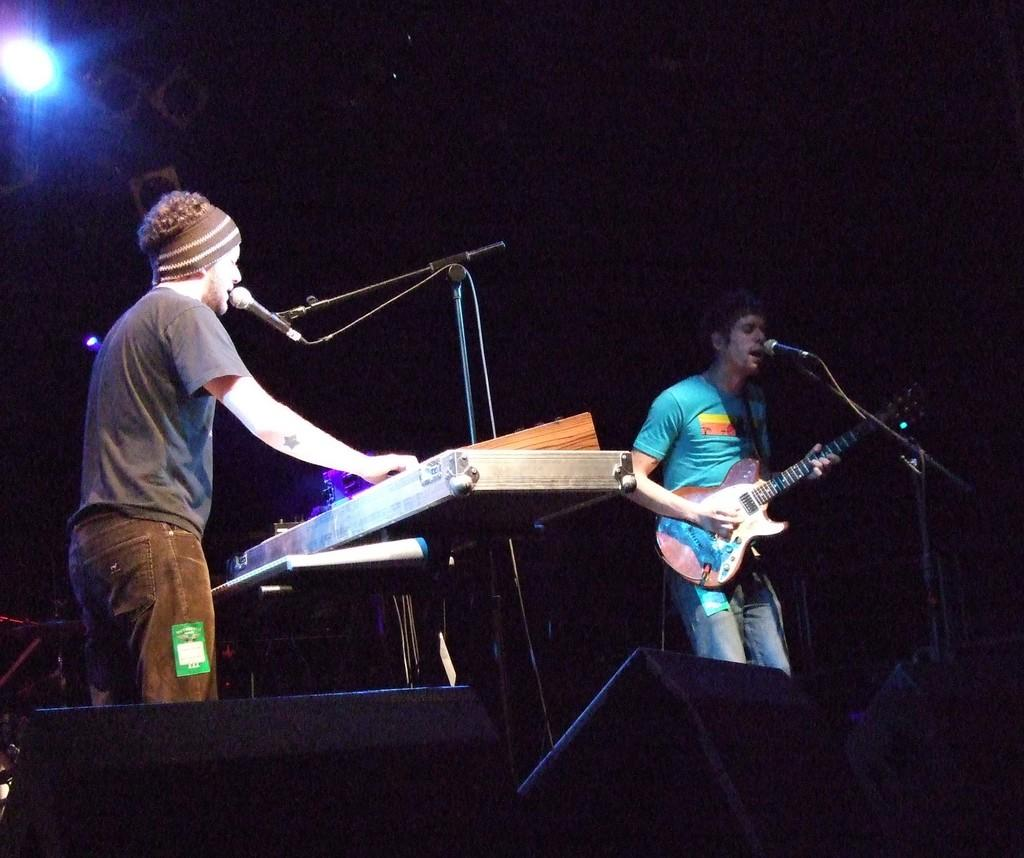How many people are in the image? There are two persons in the image. What are the two persons doing in the image? The two persons are standing in front of a microphone. What is one person playing in the image? One person is playing a guitar. What is the other person playing in the image? The other person is playing a musical instrument. Are there any slopes visible in the image? There is no mention of a slope in the image, so it cannot be determined if one is present. Can you see any giants in the image? There is no mention of giants in the image, so it cannot be determined if any are present. 